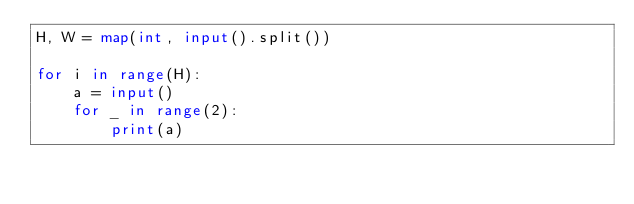Convert code to text. <code><loc_0><loc_0><loc_500><loc_500><_Python_>H, W = map(int, input().split())

for i in range(H):
    a = input()
    for _ in range(2):
        print(a)
</code> 